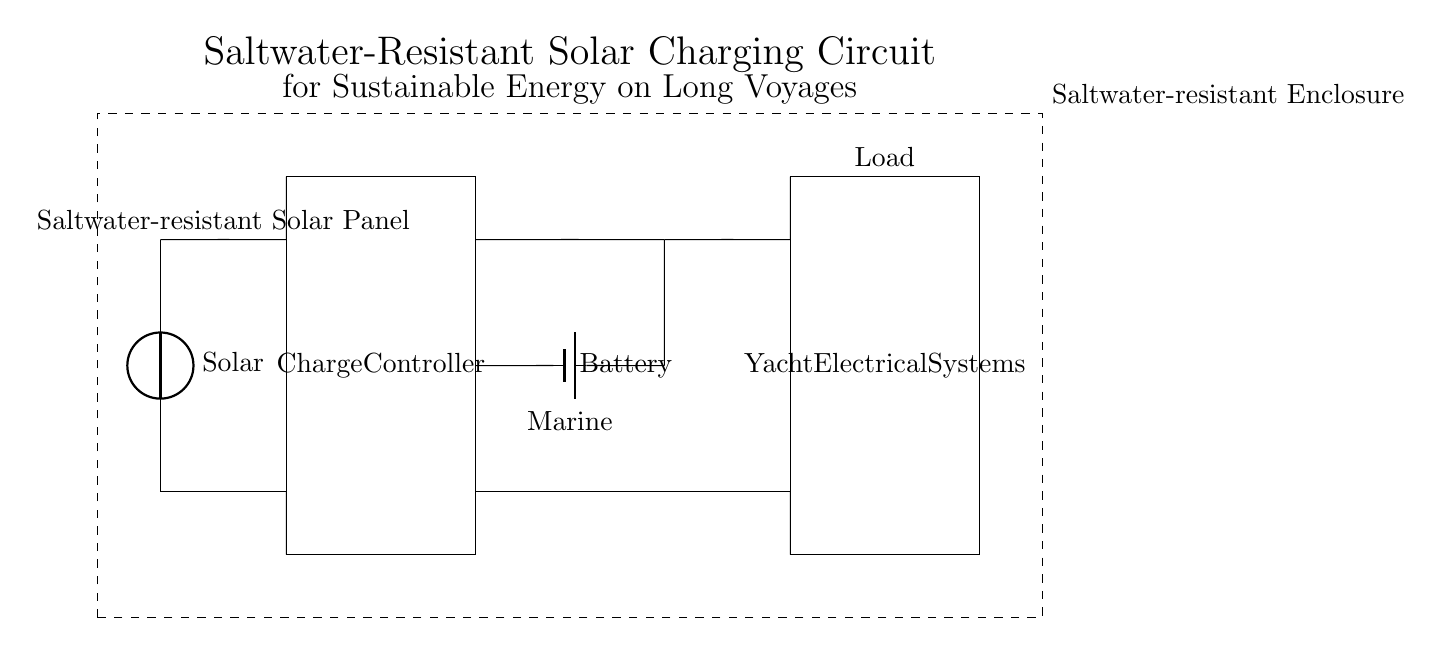What type of solar panel is used in this circuit? The circuit explicitly labels the solar panel as a "Saltwater-resistant Solar Panel," indicating its material suitability for marine environments.
Answer: Saltwater-resistant Solar Panel What is the function of the charge controller? The charge controller is designed to manage the charging of the battery from the solar panel, ensuring that the battery is charged effectively without overcharging, as represented in the diagram.
Answer: Manage battery charging What is the storage component in this circuit? The diagram identifies a battery labeled as "Marine," which serves as the energy storage component for the solar charging circuit, allowing for energy to be available when sunlight is not present.
Answer: Marine battery How many main components are present in the circuit? By counting the represented distinct components—solar panel, charge controller, battery, and load—it can be determined that there are four main components depicted in the circuit diagram.
Answer: Four What type of enclosure is shown in this circuit? The diagram indicates a "Saltwater-resistant Enclosure," suggesting that all components are housed in a protective casing to prevent corrosion from saltwater exposure.
Answer: Saltwater-resistant enclosure What is the purpose of the load in this circuit? The load is labeled as "Yacht Electrical Systems." This indicates it utilizes the energy stored in the battery to power various electrical devices on the yacht, thus highlighting its functional role in the circuit.
Answer: Yacht Electrical Systems 